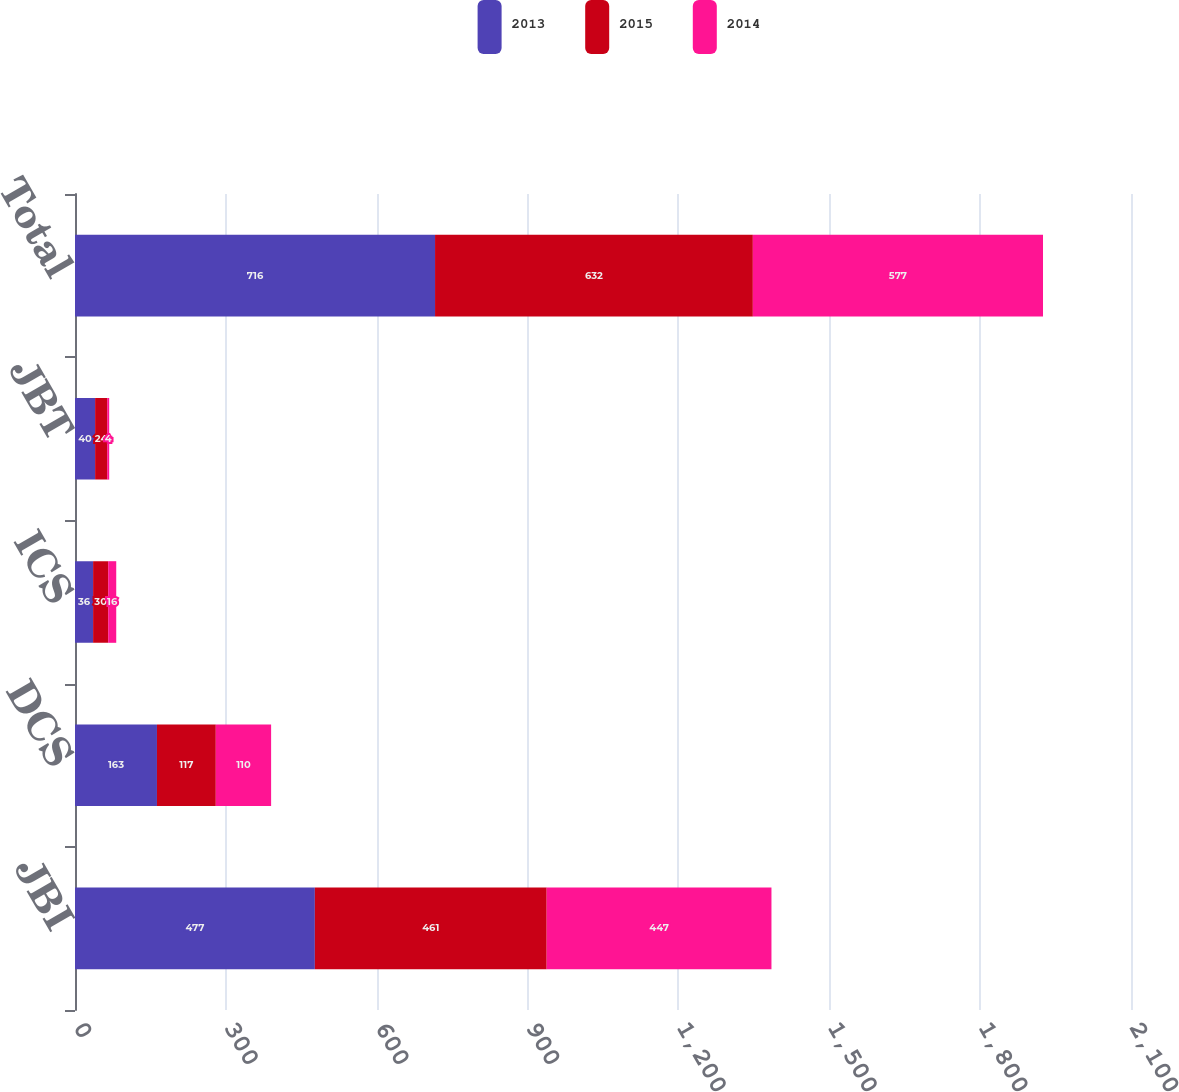Convert chart. <chart><loc_0><loc_0><loc_500><loc_500><stacked_bar_chart><ecel><fcel>JBI<fcel>DCS<fcel>ICS<fcel>JBT<fcel>Total<nl><fcel>2013<fcel>477<fcel>163<fcel>36<fcel>40<fcel>716<nl><fcel>2015<fcel>461<fcel>117<fcel>30<fcel>24<fcel>632<nl><fcel>2014<fcel>447<fcel>110<fcel>16<fcel>4<fcel>577<nl></chart> 